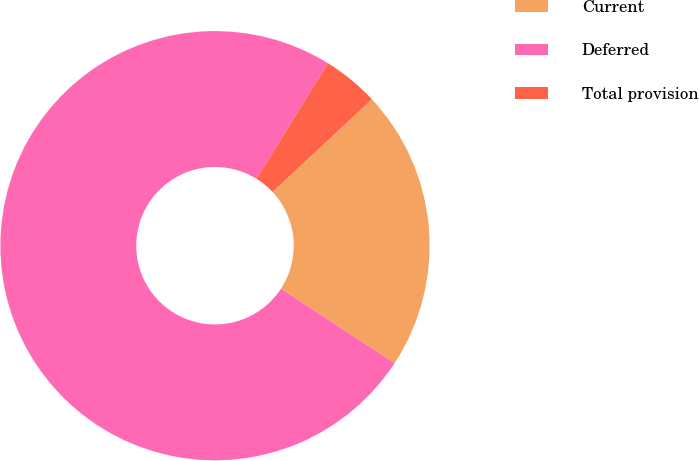Convert chart to OTSL. <chart><loc_0><loc_0><loc_500><loc_500><pie_chart><fcel>Current<fcel>Deferred<fcel>Total provision<nl><fcel>21.16%<fcel>74.6%<fcel>4.23%<nl></chart> 